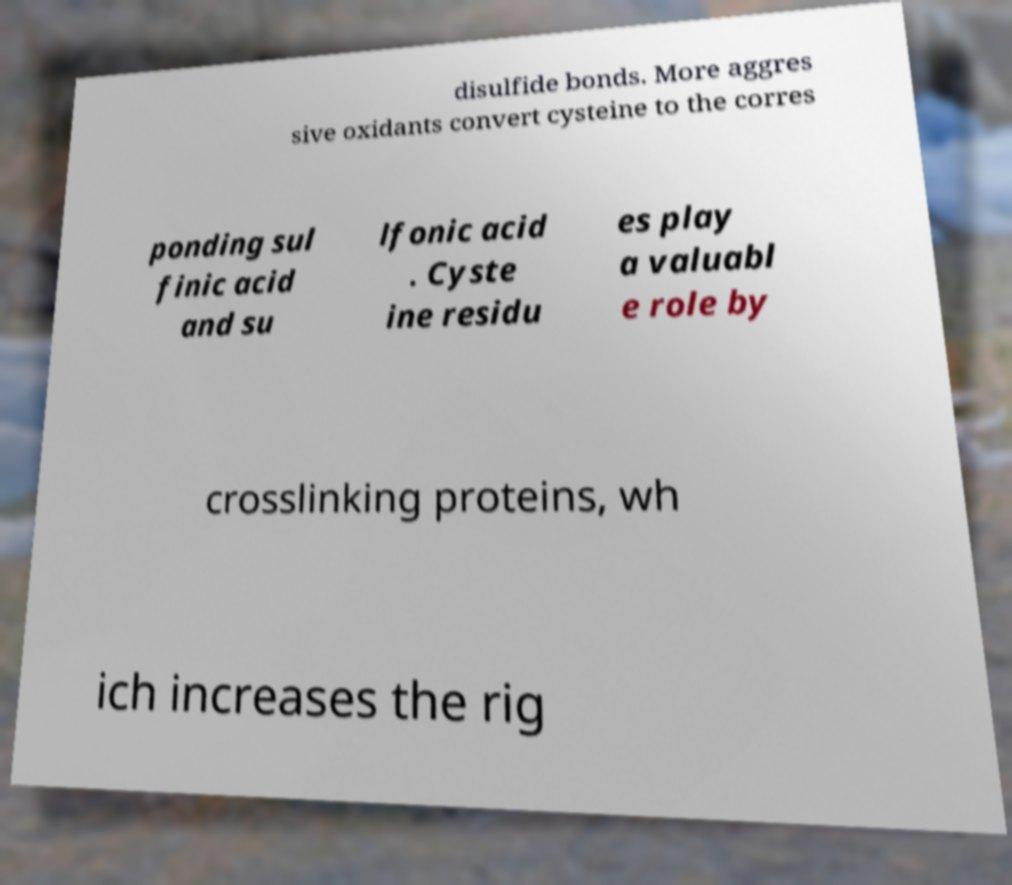For documentation purposes, I need the text within this image transcribed. Could you provide that? disulfide bonds. More aggres sive oxidants convert cysteine to the corres ponding sul finic acid and su lfonic acid . Cyste ine residu es play a valuabl e role by crosslinking proteins, wh ich increases the rig 